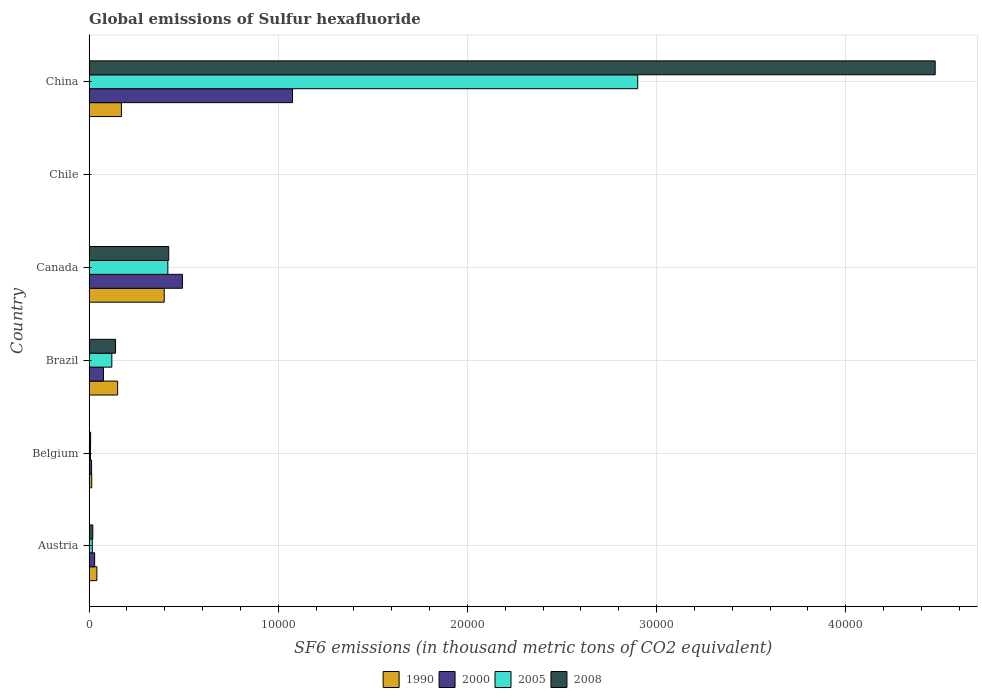How many groups of bars are there?
Your answer should be very brief. 6. What is the label of the 4th group of bars from the top?
Your answer should be compact. Brazil. What is the global emissions of Sulfur hexafluoride in 1990 in Belgium?
Provide a short and direct response. 138.5. Across all countries, what is the maximum global emissions of Sulfur hexafluoride in 2008?
Give a very brief answer. 4.47e+04. In which country was the global emissions of Sulfur hexafluoride in 2000 maximum?
Your response must be concise. China. What is the total global emissions of Sulfur hexafluoride in 2008 in the graph?
Provide a short and direct response. 5.06e+04. What is the difference between the global emissions of Sulfur hexafluoride in 2000 in Brazil and that in Canada?
Offer a terse response. -4176.4. What is the difference between the global emissions of Sulfur hexafluoride in 2008 in Austria and the global emissions of Sulfur hexafluoride in 2000 in Chile?
Give a very brief answer. 189.7. What is the average global emissions of Sulfur hexafluoride in 1990 per country?
Make the answer very short. 1292.42. What is the difference between the global emissions of Sulfur hexafluoride in 1990 and global emissions of Sulfur hexafluoride in 2008 in Belgium?
Keep it short and to the point. 57.6. What is the ratio of the global emissions of Sulfur hexafluoride in 2000 in Austria to that in Canada?
Ensure brevity in your answer.  0.06. What is the difference between the highest and the second highest global emissions of Sulfur hexafluoride in 2008?
Offer a very short reply. 4.05e+04. What is the difference between the highest and the lowest global emissions of Sulfur hexafluoride in 1990?
Your answer should be compact. 3955.3. Is it the case that in every country, the sum of the global emissions of Sulfur hexafluoride in 2000 and global emissions of Sulfur hexafluoride in 2005 is greater than the sum of global emissions of Sulfur hexafluoride in 2008 and global emissions of Sulfur hexafluoride in 1990?
Provide a succinct answer. No. How many bars are there?
Provide a succinct answer. 24. How many countries are there in the graph?
Offer a very short reply. 6. Does the graph contain any zero values?
Make the answer very short. No. Where does the legend appear in the graph?
Your answer should be very brief. Bottom center. What is the title of the graph?
Provide a succinct answer. Global emissions of Sulfur hexafluoride. What is the label or title of the X-axis?
Offer a very short reply. SF6 emissions (in thousand metric tons of CO2 equivalent). What is the SF6 emissions (in thousand metric tons of CO2 equivalent) in 1990 in Austria?
Make the answer very short. 411.2. What is the SF6 emissions (in thousand metric tons of CO2 equivalent) in 2000 in Austria?
Provide a succinct answer. 294.4. What is the SF6 emissions (in thousand metric tons of CO2 equivalent) of 2005 in Austria?
Your response must be concise. 169. What is the SF6 emissions (in thousand metric tons of CO2 equivalent) of 2008 in Austria?
Ensure brevity in your answer.  196.4. What is the SF6 emissions (in thousand metric tons of CO2 equivalent) of 1990 in Belgium?
Your response must be concise. 138.5. What is the SF6 emissions (in thousand metric tons of CO2 equivalent) in 2000 in Belgium?
Ensure brevity in your answer.  131.7. What is the SF6 emissions (in thousand metric tons of CO2 equivalent) of 2005 in Belgium?
Your answer should be very brief. 72.9. What is the SF6 emissions (in thousand metric tons of CO2 equivalent) of 2008 in Belgium?
Your answer should be compact. 80.9. What is the SF6 emissions (in thousand metric tons of CO2 equivalent) of 1990 in Brazil?
Provide a short and direct response. 1507.9. What is the SF6 emissions (in thousand metric tons of CO2 equivalent) in 2000 in Brazil?
Give a very brief answer. 758.7. What is the SF6 emissions (in thousand metric tons of CO2 equivalent) in 2005 in Brazil?
Your answer should be very brief. 1202. What is the SF6 emissions (in thousand metric tons of CO2 equivalent) in 2008 in Brazil?
Offer a very short reply. 1397.3. What is the SF6 emissions (in thousand metric tons of CO2 equivalent) of 1990 in Canada?
Give a very brief answer. 3971.8. What is the SF6 emissions (in thousand metric tons of CO2 equivalent) in 2000 in Canada?
Give a very brief answer. 4935.1. What is the SF6 emissions (in thousand metric tons of CO2 equivalent) in 2005 in Canada?
Ensure brevity in your answer.  4163.8. What is the SF6 emissions (in thousand metric tons of CO2 equivalent) of 2008 in Canada?
Your answer should be very brief. 4208.8. What is the SF6 emissions (in thousand metric tons of CO2 equivalent) in 1990 in China?
Your response must be concise. 1708.6. What is the SF6 emissions (in thousand metric tons of CO2 equivalent) of 2000 in China?
Your response must be concise. 1.08e+04. What is the SF6 emissions (in thousand metric tons of CO2 equivalent) of 2005 in China?
Your response must be concise. 2.90e+04. What is the SF6 emissions (in thousand metric tons of CO2 equivalent) in 2008 in China?
Keep it short and to the point. 4.47e+04. Across all countries, what is the maximum SF6 emissions (in thousand metric tons of CO2 equivalent) in 1990?
Give a very brief answer. 3971.8. Across all countries, what is the maximum SF6 emissions (in thousand metric tons of CO2 equivalent) in 2000?
Offer a very short reply. 1.08e+04. Across all countries, what is the maximum SF6 emissions (in thousand metric tons of CO2 equivalent) of 2005?
Your answer should be compact. 2.90e+04. Across all countries, what is the maximum SF6 emissions (in thousand metric tons of CO2 equivalent) in 2008?
Your answer should be very brief. 4.47e+04. What is the total SF6 emissions (in thousand metric tons of CO2 equivalent) of 1990 in the graph?
Offer a very short reply. 7754.5. What is the total SF6 emissions (in thousand metric tons of CO2 equivalent) in 2000 in the graph?
Provide a succinct answer. 1.69e+04. What is the total SF6 emissions (in thousand metric tons of CO2 equivalent) of 2005 in the graph?
Offer a terse response. 3.46e+04. What is the total SF6 emissions (in thousand metric tons of CO2 equivalent) in 2008 in the graph?
Keep it short and to the point. 5.06e+04. What is the difference between the SF6 emissions (in thousand metric tons of CO2 equivalent) of 1990 in Austria and that in Belgium?
Make the answer very short. 272.7. What is the difference between the SF6 emissions (in thousand metric tons of CO2 equivalent) of 2000 in Austria and that in Belgium?
Provide a short and direct response. 162.7. What is the difference between the SF6 emissions (in thousand metric tons of CO2 equivalent) in 2005 in Austria and that in Belgium?
Provide a succinct answer. 96.1. What is the difference between the SF6 emissions (in thousand metric tons of CO2 equivalent) of 2008 in Austria and that in Belgium?
Your answer should be very brief. 115.5. What is the difference between the SF6 emissions (in thousand metric tons of CO2 equivalent) of 1990 in Austria and that in Brazil?
Keep it short and to the point. -1096.7. What is the difference between the SF6 emissions (in thousand metric tons of CO2 equivalent) in 2000 in Austria and that in Brazil?
Make the answer very short. -464.3. What is the difference between the SF6 emissions (in thousand metric tons of CO2 equivalent) in 2005 in Austria and that in Brazil?
Your response must be concise. -1033. What is the difference between the SF6 emissions (in thousand metric tons of CO2 equivalent) of 2008 in Austria and that in Brazil?
Provide a succinct answer. -1200.9. What is the difference between the SF6 emissions (in thousand metric tons of CO2 equivalent) of 1990 in Austria and that in Canada?
Make the answer very short. -3560.6. What is the difference between the SF6 emissions (in thousand metric tons of CO2 equivalent) of 2000 in Austria and that in Canada?
Offer a terse response. -4640.7. What is the difference between the SF6 emissions (in thousand metric tons of CO2 equivalent) of 2005 in Austria and that in Canada?
Keep it short and to the point. -3994.8. What is the difference between the SF6 emissions (in thousand metric tons of CO2 equivalent) in 2008 in Austria and that in Canada?
Your answer should be compact. -4012.4. What is the difference between the SF6 emissions (in thousand metric tons of CO2 equivalent) in 1990 in Austria and that in Chile?
Your response must be concise. 394.7. What is the difference between the SF6 emissions (in thousand metric tons of CO2 equivalent) of 2000 in Austria and that in Chile?
Offer a terse response. 287.7. What is the difference between the SF6 emissions (in thousand metric tons of CO2 equivalent) of 2005 in Austria and that in Chile?
Ensure brevity in your answer.  160. What is the difference between the SF6 emissions (in thousand metric tons of CO2 equivalent) of 2008 in Austria and that in Chile?
Offer a very short reply. 188.5. What is the difference between the SF6 emissions (in thousand metric tons of CO2 equivalent) of 1990 in Austria and that in China?
Provide a succinct answer. -1297.4. What is the difference between the SF6 emissions (in thousand metric tons of CO2 equivalent) in 2000 in Austria and that in China?
Offer a terse response. -1.05e+04. What is the difference between the SF6 emissions (in thousand metric tons of CO2 equivalent) in 2005 in Austria and that in China?
Provide a short and direct response. -2.88e+04. What is the difference between the SF6 emissions (in thousand metric tons of CO2 equivalent) of 2008 in Austria and that in China?
Ensure brevity in your answer.  -4.45e+04. What is the difference between the SF6 emissions (in thousand metric tons of CO2 equivalent) of 1990 in Belgium and that in Brazil?
Your response must be concise. -1369.4. What is the difference between the SF6 emissions (in thousand metric tons of CO2 equivalent) of 2000 in Belgium and that in Brazil?
Your response must be concise. -627. What is the difference between the SF6 emissions (in thousand metric tons of CO2 equivalent) of 2005 in Belgium and that in Brazil?
Make the answer very short. -1129.1. What is the difference between the SF6 emissions (in thousand metric tons of CO2 equivalent) in 2008 in Belgium and that in Brazil?
Make the answer very short. -1316.4. What is the difference between the SF6 emissions (in thousand metric tons of CO2 equivalent) of 1990 in Belgium and that in Canada?
Your answer should be very brief. -3833.3. What is the difference between the SF6 emissions (in thousand metric tons of CO2 equivalent) in 2000 in Belgium and that in Canada?
Ensure brevity in your answer.  -4803.4. What is the difference between the SF6 emissions (in thousand metric tons of CO2 equivalent) in 2005 in Belgium and that in Canada?
Make the answer very short. -4090.9. What is the difference between the SF6 emissions (in thousand metric tons of CO2 equivalent) of 2008 in Belgium and that in Canada?
Your answer should be compact. -4127.9. What is the difference between the SF6 emissions (in thousand metric tons of CO2 equivalent) in 1990 in Belgium and that in Chile?
Your response must be concise. 122. What is the difference between the SF6 emissions (in thousand metric tons of CO2 equivalent) of 2000 in Belgium and that in Chile?
Give a very brief answer. 125. What is the difference between the SF6 emissions (in thousand metric tons of CO2 equivalent) in 2005 in Belgium and that in Chile?
Provide a short and direct response. 63.9. What is the difference between the SF6 emissions (in thousand metric tons of CO2 equivalent) of 2008 in Belgium and that in Chile?
Offer a terse response. 73. What is the difference between the SF6 emissions (in thousand metric tons of CO2 equivalent) of 1990 in Belgium and that in China?
Keep it short and to the point. -1570.1. What is the difference between the SF6 emissions (in thousand metric tons of CO2 equivalent) in 2000 in Belgium and that in China?
Offer a terse response. -1.06e+04. What is the difference between the SF6 emissions (in thousand metric tons of CO2 equivalent) of 2005 in Belgium and that in China?
Make the answer very short. -2.89e+04. What is the difference between the SF6 emissions (in thousand metric tons of CO2 equivalent) of 2008 in Belgium and that in China?
Make the answer very short. -4.46e+04. What is the difference between the SF6 emissions (in thousand metric tons of CO2 equivalent) in 1990 in Brazil and that in Canada?
Make the answer very short. -2463.9. What is the difference between the SF6 emissions (in thousand metric tons of CO2 equivalent) in 2000 in Brazil and that in Canada?
Your response must be concise. -4176.4. What is the difference between the SF6 emissions (in thousand metric tons of CO2 equivalent) of 2005 in Brazil and that in Canada?
Provide a succinct answer. -2961.8. What is the difference between the SF6 emissions (in thousand metric tons of CO2 equivalent) in 2008 in Brazil and that in Canada?
Your answer should be very brief. -2811.5. What is the difference between the SF6 emissions (in thousand metric tons of CO2 equivalent) of 1990 in Brazil and that in Chile?
Your answer should be very brief. 1491.4. What is the difference between the SF6 emissions (in thousand metric tons of CO2 equivalent) of 2000 in Brazil and that in Chile?
Your answer should be compact. 752. What is the difference between the SF6 emissions (in thousand metric tons of CO2 equivalent) of 2005 in Brazil and that in Chile?
Your answer should be very brief. 1193. What is the difference between the SF6 emissions (in thousand metric tons of CO2 equivalent) of 2008 in Brazil and that in Chile?
Provide a short and direct response. 1389.4. What is the difference between the SF6 emissions (in thousand metric tons of CO2 equivalent) of 1990 in Brazil and that in China?
Provide a short and direct response. -200.7. What is the difference between the SF6 emissions (in thousand metric tons of CO2 equivalent) of 2000 in Brazil and that in China?
Give a very brief answer. -9994.9. What is the difference between the SF6 emissions (in thousand metric tons of CO2 equivalent) in 2005 in Brazil and that in China?
Your answer should be very brief. -2.78e+04. What is the difference between the SF6 emissions (in thousand metric tons of CO2 equivalent) of 2008 in Brazil and that in China?
Keep it short and to the point. -4.33e+04. What is the difference between the SF6 emissions (in thousand metric tons of CO2 equivalent) in 1990 in Canada and that in Chile?
Your answer should be very brief. 3955.3. What is the difference between the SF6 emissions (in thousand metric tons of CO2 equivalent) of 2000 in Canada and that in Chile?
Give a very brief answer. 4928.4. What is the difference between the SF6 emissions (in thousand metric tons of CO2 equivalent) in 2005 in Canada and that in Chile?
Keep it short and to the point. 4154.8. What is the difference between the SF6 emissions (in thousand metric tons of CO2 equivalent) of 2008 in Canada and that in Chile?
Provide a succinct answer. 4200.9. What is the difference between the SF6 emissions (in thousand metric tons of CO2 equivalent) in 1990 in Canada and that in China?
Provide a succinct answer. 2263.2. What is the difference between the SF6 emissions (in thousand metric tons of CO2 equivalent) in 2000 in Canada and that in China?
Give a very brief answer. -5818.5. What is the difference between the SF6 emissions (in thousand metric tons of CO2 equivalent) in 2005 in Canada and that in China?
Offer a very short reply. -2.48e+04. What is the difference between the SF6 emissions (in thousand metric tons of CO2 equivalent) of 2008 in Canada and that in China?
Your answer should be compact. -4.05e+04. What is the difference between the SF6 emissions (in thousand metric tons of CO2 equivalent) of 1990 in Chile and that in China?
Provide a succinct answer. -1692.1. What is the difference between the SF6 emissions (in thousand metric tons of CO2 equivalent) of 2000 in Chile and that in China?
Your answer should be compact. -1.07e+04. What is the difference between the SF6 emissions (in thousand metric tons of CO2 equivalent) in 2005 in Chile and that in China?
Offer a terse response. -2.90e+04. What is the difference between the SF6 emissions (in thousand metric tons of CO2 equivalent) of 2008 in Chile and that in China?
Keep it short and to the point. -4.47e+04. What is the difference between the SF6 emissions (in thousand metric tons of CO2 equivalent) in 1990 in Austria and the SF6 emissions (in thousand metric tons of CO2 equivalent) in 2000 in Belgium?
Offer a very short reply. 279.5. What is the difference between the SF6 emissions (in thousand metric tons of CO2 equivalent) in 1990 in Austria and the SF6 emissions (in thousand metric tons of CO2 equivalent) in 2005 in Belgium?
Provide a short and direct response. 338.3. What is the difference between the SF6 emissions (in thousand metric tons of CO2 equivalent) in 1990 in Austria and the SF6 emissions (in thousand metric tons of CO2 equivalent) in 2008 in Belgium?
Offer a very short reply. 330.3. What is the difference between the SF6 emissions (in thousand metric tons of CO2 equivalent) of 2000 in Austria and the SF6 emissions (in thousand metric tons of CO2 equivalent) of 2005 in Belgium?
Ensure brevity in your answer.  221.5. What is the difference between the SF6 emissions (in thousand metric tons of CO2 equivalent) of 2000 in Austria and the SF6 emissions (in thousand metric tons of CO2 equivalent) of 2008 in Belgium?
Your answer should be very brief. 213.5. What is the difference between the SF6 emissions (in thousand metric tons of CO2 equivalent) of 2005 in Austria and the SF6 emissions (in thousand metric tons of CO2 equivalent) of 2008 in Belgium?
Your response must be concise. 88.1. What is the difference between the SF6 emissions (in thousand metric tons of CO2 equivalent) of 1990 in Austria and the SF6 emissions (in thousand metric tons of CO2 equivalent) of 2000 in Brazil?
Your response must be concise. -347.5. What is the difference between the SF6 emissions (in thousand metric tons of CO2 equivalent) in 1990 in Austria and the SF6 emissions (in thousand metric tons of CO2 equivalent) in 2005 in Brazil?
Make the answer very short. -790.8. What is the difference between the SF6 emissions (in thousand metric tons of CO2 equivalent) of 1990 in Austria and the SF6 emissions (in thousand metric tons of CO2 equivalent) of 2008 in Brazil?
Make the answer very short. -986.1. What is the difference between the SF6 emissions (in thousand metric tons of CO2 equivalent) in 2000 in Austria and the SF6 emissions (in thousand metric tons of CO2 equivalent) in 2005 in Brazil?
Give a very brief answer. -907.6. What is the difference between the SF6 emissions (in thousand metric tons of CO2 equivalent) in 2000 in Austria and the SF6 emissions (in thousand metric tons of CO2 equivalent) in 2008 in Brazil?
Your answer should be compact. -1102.9. What is the difference between the SF6 emissions (in thousand metric tons of CO2 equivalent) in 2005 in Austria and the SF6 emissions (in thousand metric tons of CO2 equivalent) in 2008 in Brazil?
Offer a terse response. -1228.3. What is the difference between the SF6 emissions (in thousand metric tons of CO2 equivalent) in 1990 in Austria and the SF6 emissions (in thousand metric tons of CO2 equivalent) in 2000 in Canada?
Give a very brief answer. -4523.9. What is the difference between the SF6 emissions (in thousand metric tons of CO2 equivalent) in 1990 in Austria and the SF6 emissions (in thousand metric tons of CO2 equivalent) in 2005 in Canada?
Your response must be concise. -3752.6. What is the difference between the SF6 emissions (in thousand metric tons of CO2 equivalent) of 1990 in Austria and the SF6 emissions (in thousand metric tons of CO2 equivalent) of 2008 in Canada?
Provide a succinct answer. -3797.6. What is the difference between the SF6 emissions (in thousand metric tons of CO2 equivalent) in 2000 in Austria and the SF6 emissions (in thousand metric tons of CO2 equivalent) in 2005 in Canada?
Your answer should be very brief. -3869.4. What is the difference between the SF6 emissions (in thousand metric tons of CO2 equivalent) of 2000 in Austria and the SF6 emissions (in thousand metric tons of CO2 equivalent) of 2008 in Canada?
Make the answer very short. -3914.4. What is the difference between the SF6 emissions (in thousand metric tons of CO2 equivalent) of 2005 in Austria and the SF6 emissions (in thousand metric tons of CO2 equivalent) of 2008 in Canada?
Keep it short and to the point. -4039.8. What is the difference between the SF6 emissions (in thousand metric tons of CO2 equivalent) in 1990 in Austria and the SF6 emissions (in thousand metric tons of CO2 equivalent) in 2000 in Chile?
Offer a very short reply. 404.5. What is the difference between the SF6 emissions (in thousand metric tons of CO2 equivalent) of 1990 in Austria and the SF6 emissions (in thousand metric tons of CO2 equivalent) of 2005 in Chile?
Your answer should be very brief. 402.2. What is the difference between the SF6 emissions (in thousand metric tons of CO2 equivalent) in 1990 in Austria and the SF6 emissions (in thousand metric tons of CO2 equivalent) in 2008 in Chile?
Your response must be concise. 403.3. What is the difference between the SF6 emissions (in thousand metric tons of CO2 equivalent) of 2000 in Austria and the SF6 emissions (in thousand metric tons of CO2 equivalent) of 2005 in Chile?
Provide a short and direct response. 285.4. What is the difference between the SF6 emissions (in thousand metric tons of CO2 equivalent) in 2000 in Austria and the SF6 emissions (in thousand metric tons of CO2 equivalent) in 2008 in Chile?
Your answer should be very brief. 286.5. What is the difference between the SF6 emissions (in thousand metric tons of CO2 equivalent) in 2005 in Austria and the SF6 emissions (in thousand metric tons of CO2 equivalent) in 2008 in Chile?
Ensure brevity in your answer.  161.1. What is the difference between the SF6 emissions (in thousand metric tons of CO2 equivalent) of 1990 in Austria and the SF6 emissions (in thousand metric tons of CO2 equivalent) of 2000 in China?
Keep it short and to the point. -1.03e+04. What is the difference between the SF6 emissions (in thousand metric tons of CO2 equivalent) in 1990 in Austria and the SF6 emissions (in thousand metric tons of CO2 equivalent) in 2005 in China?
Offer a terse response. -2.86e+04. What is the difference between the SF6 emissions (in thousand metric tons of CO2 equivalent) of 1990 in Austria and the SF6 emissions (in thousand metric tons of CO2 equivalent) of 2008 in China?
Your answer should be very brief. -4.43e+04. What is the difference between the SF6 emissions (in thousand metric tons of CO2 equivalent) in 2000 in Austria and the SF6 emissions (in thousand metric tons of CO2 equivalent) in 2005 in China?
Your answer should be compact. -2.87e+04. What is the difference between the SF6 emissions (in thousand metric tons of CO2 equivalent) in 2000 in Austria and the SF6 emissions (in thousand metric tons of CO2 equivalent) in 2008 in China?
Keep it short and to the point. -4.44e+04. What is the difference between the SF6 emissions (in thousand metric tons of CO2 equivalent) in 2005 in Austria and the SF6 emissions (in thousand metric tons of CO2 equivalent) in 2008 in China?
Offer a very short reply. -4.46e+04. What is the difference between the SF6 emissions (in thousand metric tons of CO2 equivalent) of 1990 in Belgium and the SF6 emissions (in thousand metric tons of CO2 equivalent) of 2000 in Brazil?
Make the answer very short. -620.2. What is the difference between the SF6 emissions (in thousand metric tons of CO2 equivalent) of 1990 in Belgium and the SF6 emissions (in thousand metric tons of CO2 equivalent) of 2005 in Brazil?
Offer a very short reply. -1063.5. What is the difference between the SF6 emissions (in thousand metric tons of CO2 equivalent) of 1990 in Belgium and the SF6 emissions (in thousand metric tons of CO2 equivalent) of 2008 in Brazil?
Offer a terse response. -1258.8. What is the difference between the SF6 emissions (in thousand metric tons of CO2 equivalent) of 2000 in Belgium and the SF6 emissions (in thousand metric tons of CO2 equivalent) of 2005 in Brazil?
Offer a terse response. -1070.3. What is the difference between the SF6 emissions (in thousand metric tons of CO2 equivalent) in 2000 in Belgium and the SF6 emissions (in thousand metric tons of CO2 equivalent) in 2008 in Brazil?
Ensure brevity in your answer.  -1265.6. What is the difference between the SF6 emissions (in thousand metric tons of CO2 equivalent) in 2005 in Belgium and the SF6 emissions (in thousand metric tons of CO2 equivalent) in 2008 in Brazil?
Keep it short and to the point. -1324.4. What is the difference between the SF6 emissions (in thousand metric tons of CO2 equivalent) of 1990 in Belgium and the SF6 emissions (in thousand metric tons of CO2 equivalent) of 2000 in Canada?
Keep it short and to the point. -4796.6. What is the difference between the SF6 emissions (in thousand metric tons of CO2 equivalent) in 1990 in Belgium and the SF6 emissions (in thousand metric tons of CO2 equivalent) in 2005 in Canada?
Keep it short and to the point. -4025.3. What is the difference between the SF6 emissions (in thousand metric tons of CO2 equivalent) in 1990 in Belgium and the SF6 emissions (in thousand metric tons of CO2 equivalent) in 2008 in Canada?
Your answer should be very brief. -4070.3. What is the difference between the SF6 emissions (in thousand metric tons of CO2 equivalent) in 2000 in Belgium and the SF6 emissions (in thousand metric tons of CO2 equivalent) in 2005 in Canada?
Offer a very short reply. -4032.1. What is the difference between the SF6 emissions (in thousand metric tons of CO2 equivalent) of 2000 in Belgium and the SF6 emissions (in thousand metric tons of CO2 equivalent) of 2008 in Canada?
Make the answer very short. -4077.1. What is the difference between the SF6 emissions (in thousand metric tons of CO2 equivalent) of 2005 in Belgium and the SF6 emissions (in thousand metric tons of CO2 equivalent) of 2008 in Canada?
Provide a succinct answer. -4135.9. What is the difference between the SF6 emissions (in thousand metric tons of CO2 equivalent) in 1990 in Belgium and the SF6 emissions (in thousand metric tons of CO2 equivalent) in 2000 in Chile?
Offer a very short reply. 131.8. What is the difference between the SF6 emissions (in thousand metric tons of CO2 equivalent) of 1990 in Belgium and the SF6 emissions (in thousand metric tons of CO2 equivalent) of 2005 in Chile?
Make the answer very short. 129.5. What is the difference between the SF6 emissions (in thousand metric tons of CO2 equivalent) of 1990 in Belgium and the SF6 emissions (in thousand metric tons of CO2 equivalent) of 2008 in Chile?
Provide a succinct answer. 130.6. What is the difference between the SF6 emissions (in thousand metric tons of CO2 equivalent) in 2000 in Belgium and the SF6 emissions (in thousand metric tons of CO2 equivalent) in 2005 in Chile?
Ensure brevity in your answer.  122.7. What is the difference between the SF6 emissions (in thousand metric tons of CO2 equivalent) of 2000 in Belgium and the SF6 emissions (in thousand metric tons of CO2 equivalent) of 2008 in Chile?
Give a very brief answer. 123.8. What is the difference between the SF6 emissions (in thousand metric tons of CO2 equivalent) of 2005 in Belgium and the SF6 emissions (in thousand metric tons of CO2 equivalent) of 2008 in Chile?
Your response must be concise. 65. What is the difference between the SF6 emissions (in thousand metric tons of CO2 equivalent) of 1990 in Belgium and the SF6 emissions (in thousand metric tons of CO2 equivalent) of 2000 in China?
Give a very brief answer. -1.06e+04. What is the difference between the SF6 emissions (in thousand metric tons of CO2 equivalent) of 1990 in Belgium and the SF6 emissions (in thousand metric tons of CO2 equivalent) of 2005 in China?
Ensure brevity in your answer.  -2.89e+04. What is the difference between the SF6 emissions (in thousand metric tons of CO2 equivalent) of 1990 in Belgium and the SF6 emissions (in thousand metric tons of CO2 equivalent) of 2008 in China?
Provide a succinct answer. -4.46e+04. What is the difference between the SF6 emissions (in thousand metric tons of CO2 equivalent) of 2000 in Belgium and the SF6 emissions (in thousand metric tons of CO2 equivalent) of 2005 in China?
Provide a succinct answer. -2.89e+04. What is the difference between the SF6 emissions (in thousand metric tons of CO2 equivalent) in 2000 in Belgium and the SF6 emissions (in thousand metric tons of CO2 equivalent) in 2008 in China?
Provide a succinct answer. -4.46e+04. What is the difference between the SF6 emissions (in thousand metric tons of CO2 equivalent) of 2005 in Belgium and the SF6 emissions (in thousand metric tons of CO2 equivalent) of 2008 in China?
Your answer should be compact. -4.47e+04. What is the difference between the SF6 emissions (in thousand metric tons of CO2 equivalent) of 1990 in Brazil and the SF6 emissions (in thousand metric tons of CO2 equivalent) of 2000 in Canada?
Keep it short and to the point. -3427.2. What is the difference between the SF6 emissions (in thousand metric tons of CO2 equivalent) of 1990 in Brazil and the SF6 emissions (in thousand metric tons of CO2 equivalent) of 2005 in Canada?
Offer a terse response. -2655.9. What is the difference between the SF6 emissions (in thousand metric tons of CO2 equivalent) of 1990 in Brazil and the SF6 emissions (in thousand metric tons of CO2 equivalent) of 2008 in Canada?
Your response must be concise. -2700.9. What is the difference between the SF6 emissions (in thousand metric tons of CO2 equivalent) of 2000 in Brazil and the SF6 emissions (in thousand metric tons of CO2 equivalent) of 2005 in Canada?
Your response must be concise. -3405.1. What is the difference between the SF6 emissions (in thousand metric tons of CO2 equivalent) of 2000 in Brazil and the SF6 emissions (in thousand metric tons of CO2 equivalent) of 2008 in Canada?
Provide a short and direct response. -3450.1. What is the difference between the SF6 emissions (in thousand metric tons of CO2 equivalent) of 2005 in Brazil and the SF6 emissions (in thousand metric tons of CO2 equivalent) of 2008 in Canada?
Your answer should be very brief. -3006.8. What is the difference between the SF6 emissions (in thousand metric tons of CO2 equivalent) in 1990 in Brazil and the SF6 emissions (in thousand metric tons of CO2 equivalent) in 2000 in Chile?
Give a very brief answer. 1501.2. What is the difference between the SF6 emissions (in thousand metric tons of CO2 equivalent) of 1990 in Brazil and the SF6 emissions (in thousand metric tons of CO2 equivalent) of 2005 in Chile?
Your answer should be very brief. 1498.9. What is the difference between the SF6 emissions (in thousand metric tons of CO2 equivalent) of 1990 in Brazil and the SF6 emissions (in thousand metric tons of CO2 equivalent) of 2008 in Chile?
Your response must be concise. 1500. What is the difference between the SF6 emissions (in thousand metric tons of CO2 equivalent) in 2000 in Brazil and the SF6 emissions (in thousand metric tons of CO2 equivalent) in 2005 in Chile?
Your answer should be very brief. 749.7. What is the difference between the SF6 emissions (in thousand metric tons of CO2 equivalent) of 2000 in Brazil and the SF6 emissions (in thousand metric tons of CO2 equivalent) of 2008 in Chile?
Ensure brevity in your answer.  750.8. What is the difference between the SF6 emissions (in thousand metric tons of CO2 equivalent) in 2005 in Brazil and the SF6 emissions (in thousand metric tons of CO2 equivalent) in 2008 in Chile?
Make the answer very short. 1194.1. What is the difference between the SF6 emissions (in thousand metric tons of CO2 equivalent) in 1990 in Brazil and the SF6 emissions (in thousand metric tons of CO2 equivalent) in 2000 in China?
Your answer should be very brief. -9245.7. What is the difference between the SF6 emissions (in thousand metric tons of CO2 equivalent) in 1990 in Brazil and the SF6 emissions (in thousand metric tons of CO2 equivalent) in 2005 in China?
Your response must be concise. -2.75e+04. What is the difference between the SF6 emissions (in thousand metric tons of CO2 equivalent) in 1990 in Brazil and the SF6 emissions (in thousand metric tons of CO2 equivalent) in 2008 in China?
Keep it short and to the point. -4.32e+04. What is the difference between the SF6 emissions (in thousand metric tons of CO2 equivalent) in 2000 in Brazil and the SF6 emissions (in thousand metric tons of CO2 equivalent) in 2005 in China?
Offer a terse response. -2.82e+04. What is the difference between the SF6 emissions (in thousand metric tons of CO2 equivalent) of 2000 in Brazil and the SF6 emissions (in thousand metric tons of CO2 equivalent) of 2008 in China?
Your answer should be very brief. -4.40e+04. What is the difference between the SF6 emissions (in thousand metric tons of CO2 equivalent) in 2005 in Brazil and the SF6 emissions (in thousand metric tons of CO2 equivalent) in 2008 in China?
Give a very brief answer. -4.35e+04. What is the difference between the SF6 emissions (in thousand metric tons of CO2 equivalent) in 1990 in Canada and the SF6 emissions (in thousand metric tons of CO2 equivalent) in 2000 in Chile?
Provide a short and direct response. 3965.1. What is the difference between the SF6 emissions (in thousand metric tons of CO2 equivalent) in 1990 in Canada and the SF6 emissions (in thousand metric tons of CO2 equivalent) in 2005 in Chile?
Keep it short and to the point. 3962.8. What is the difference between the SF6 emissions (in thousand metric tons of CO2 equivalent) in 1990 in Canada and the SF6 emissions (in thousand metric tons of CO2 equivalent) in 2008 in Chile?
Make the answer very short. 3963.9. What is the difference between the SF6 emissions (in thousand metric tons of CO2 equivalent) of 2000 in Canada and the SF6 emissions (in thousand metric tons of CO2 equivalent) of 2005 in Chile?
Provide a succinct answer. 4926.1. What is the difference between the SF6 emissions (in thousand metric tons of CO2 equivalent) in 2000 in Canada and the SF6 emissions (in thousand metric tons of CO2 equivalent) in 2008 in Chile?
Make the answer very short. 4927.2. What is the difference between the SF6 emissions (in thousand metric tons of CO2 equivalent) of 2005 in Canada and the SF6 emissions (in thousand metric tons of CO2 equivalent) of 2008 in Chile?
Your response must be concise. 4155.9. What is the difference between the SF6 emissions (in thousand metric tons of CO2 equivalent) in 1990 in Canada and the SF6 emissions (in thousand metric tons of CO2 equivalent) in 2000 in China?
Your response must be concise. -6781.8. What is the difference between the SF6 emissions (in thousand metric tons of CO2 equivalent) in 1990 in Canada and the SF6 emissions (in thousand metric tons of CO2 equivalent) in 2005 in China?
Your answer should be compact. -2.50e+04. What is the difference between the SF6 emissions (in thousand metric tons of CO2 equivalent) of 1990 in Canada and the SF6 emissions (in thousand metric tons of CO2 equivalent) of 2008 in China?
Ensure brevity in your answer.  -4.08e+04. What is the difference between the SF6 emissions (in thousand metric tons of CO2 equivalent) of 2000 in Canada and the SF6 emissions (in thousand metric tons of CO2 equivalent) of 2005 in China?
Give a very brief answer. -2.41e+04. What is the difference between the SF6 emissions (in thousand metric tons of CO2 equivalent) of 2000 in Canada and the SF6 emissions (in thousand metric tons of CO2 equivalent) of 2008 in China?
Make the answer very short. -3.98e+04. What is the difference between the SF6 emissions (in thousand metric tons of CO2 equivalent) in 2005 in Canada and the SF6 emissions (in thousand metric tons of CO2 equivalent) in 2008 in China?
Your response must be concise. -4.06e+04. What is the difference between the SF6 emissions (in thousand metric tons of CO2 equivalent) of 1990 in Chile and the SF6 emissions (in thousand metric tons of CO2 equivalent) of 2000 in China?
Your response must be concise. -1.07e+04. What is the difference between the SF6 emissions (in thousand metric tons of CO2 equivalent) of 1990 in Chile and the SF6 emissions (in thousand metric tons of CO2 equivalent) of 2005 in China?
Your response must be concise. -2.90e+04. What is the difference between the SF6 emissions (in thousand metric tons of CO2 equivalent) in 1990 in Chile and the SF6 emissions (in thousand metric tons of CO2 equivalent) in 2008 in China?
Provide a succinct answer. -4.47e+04. What is the difference between the SF6 emissions (in thousand metric tons of CO2 equivalent) in 2000 in Chile and the SF6 emissions (in thousand metric tons of CO2 equivalent) in 2005 in China?
Provide a succinct answer. -2.90e+04. What is the difference between the SF6 emissions (in thousand metric tons of CO2 equivalent) in 2000 in Chile and the SF6 emissions (in thousand metric tons of CO2 equivalent) in 2008 in China?
Your response must be concise. -4.47e+04. What is the difference between the SF6 emissions (in thousand metric tons of CO2 equivalent) in 2005 in Chile and the SF6 emissions (in thousand metric tons of CO2 equivalent) in 2008 in China?
Offer a terse response. -4.47e+04. What is the average SF6 emissions (in thousand metric tons of CO2 equivalent) of 1990 per country?
Provide a succinct answer. 1292.42. What is the average SF6 emissions (in thousand metric tons of CO2 equivalent) of 2000 per country?
Provide a short and direct response. 2813.37. What is the average SF6 emissions (in thousand metric tons of CO2 equivalent) in 2005 per country?
Give a very brief answer. 5769.57. What is the average SF6 emissions (in thousand metric tons of CO2 equivalent) in 2008 per country?
Make the answer very short. 8436.25. What is the difference between the SF6 emissions (in thousand metric tons of CO2 equivalent) of 1990 and SF6 emissions (in thousand metric tons of CO2 equivalent) of 2000 in Austria?
Provide a succinct answer. 116.8. What is the difference between the SF6 emissions (in thousand metric tons of CO2 equivalent) in 1990 and SF6 emissions (in thousand metric tons of CO2 equivalent) in 2005 in Austria?
Make the answer very short. 242.2. What is the difference between the SF6 emissions (in thousand metric tons of CO2 equivalent) in 1990 and SF6 emissions (in thousand metric tons of CO2 equivalent) in 2008 in Austria?
Your answer should be compact. 214.8. What is the difference between the SF6 emissions (in thousand metric tons of CO2 equivalent) of 2000 and SF6 emissions (in thousand metric tons of CO2 equivalent) of 2005 in Austria?
Offer a very short reply. 125.4. What is the difference between the SF6 emissions (in thousand metric tons of CO2 equivalent) of 2005 and SF6 emissions (in thousand metric tons of CO2 equivalent) of 2008 in Austria?
Offer a terse response. -27.4. What is the difference between the SF6 emissions (in thousand metric tons of CO2 equivalent) in 1990 and SF6 emissions (in thousand metric tons of CO2 equivalent) in 2000 in Belgium?
Make the answer very short. 6.8. What is the difference between the SF6 emissions (in thousand metric tons of CO2 equivalent) of 1990 and SF6 emissions (in thousand metric tons of CO2 equivalent) of 2005 in Belgium?
Ensure brevity in your answer.  65.6. What is the difference between the SF6 emissions (in thousand metric tons of CO2 equivalent) of 1990 and SF6 emissions (in thousand metric tons of CO2 equivalent) of 2008 in Belgium?
Make the answer very short. 57.6. What is the difference between the SF6 emissions (in thousand metric tons of CO2 equivalent) in 2000 and SF6 emissions (in thousand metric tons of CO2 equivalent) in 2005 in Belgium?
Offer a very short reply. 58.8. What is the difference between the SF6 emissions (in thousand metric tons of CO2 equivalent) of 2000 and SF6 emissions (in thousand metric tons of CO2 equivalent) of 2008 in Belgium?
Keep it short and to the point. 50.8. What is the difference between the SF6 emissions (in thousand metric tons of CO2 equivalent) of 1990 and SF6 emissions (in thousand metric tons of CO2 equivalent) of 2000 in Brazil?
Your answer should be very brief. 749.2. What is the difference between the SF6 emissions (in thousand metric tons of CO2 equivalent) in 1990 and SF6 emissions (in thousand metric tons of CO2 equivalent) in 2005 in Brazil?
Your response must be concise. 305.9. What is the difference between the SF6 emissions (in thousand metric tons of CO2 equivalent) in 1990 and SF6 emissions (in thousand metric tons of CO2 equivalent) in 2008 in Brazil?
Keep it short and to the point. 110.6. What is the difference between the SF6 emissions (in thousand metric tons of CO2 equivalent) of 2000 and SF6 emissions (in thousand metric tons of CO2 equivalent) of 2005 in Brazil?
Your response must be concise. -443.3. What is the difference between the SF6 emissions (in thousand metric tons of CO2 equivalent) in 2000 and SF6 emissions (in thousand metric tons of CO2 equivalent) in 2008 in Brazil?
Provide a succinct answer. -638.6. What is the difference between the SF6 emissions (in thousand metric tons of CO2 equivalent) in 2005 and SF6 emissions (in thousand metric tons of CO2 equivalent) in 2008 in Brazil?
Provide a succinct answer. -195.3. What is the difference between the SF6 emissions (in thousand metric tons of CO2 equivalent) of 1990 and SF6 emissions (in thousand metric tons of CO2 equivalent) of 2000 in Canada?
Provide a succinct answer. -963.3. What is the difference between the SF6 emissions (in thousand metric tons of CO2 equivalent) in 1990 and SF6 emissions (in thousand metric tons of CO2 equivalent) in 2005 in Canada?
Make the answer very short. -192. What is the difference between the SF6 emissions (in thousand metric tons of CO2 equivalent) of 1990 and SF6 emissions (in thousand metric tons of CO2 equivalent) of 2008 in Canada?
Offer a very short reply. -237. What is the difference between the SF6 emissions (in thousand metric tons of CO2 equivalent) in 2000 and SF6 emissions (in thousand metric tons of CO2 equivalent) in 2005 in Canada?
Your answer should be very brief. 771.3. What is the difference between the SF6 emissions (in thousand metric tons of CO2 equivalent) in 2000 and SF6 emissions (in thousand metric tons of CO2 equivalent) in 2008 in Canada?
Your answer should be compact. 726.3. What is the difference between the SF6 emissions (in thousand metric tons of CO2 equivalent) in 2005 and SF6 emissions (in thousand metric tons of CO2 equivalent) in 2008 in Canada?
Make the answer very short. -45. What is the difference between the SF6 emissions (in thousand metric tons of CO2 equivalent) of 1990 and SF6 emissions (in thousand metric tons of CO2 equivalent) of 2005 in Chile?
Your response must be concise. 7.5. What is the difference between the SF6 emissions (in thousand metric tons of CO2 equivalent) of 2000 and SF6 emissions (in thousand metric tons of CO2 equivalent) of 2005 in Chile?
Offer a terse response. -2.3. What is the difference between the SF6 emissions (in thousand metric tons of CO2 equivalent) in 2000 and SF6 emissions (in thousand metric tons of CO2 equivalent) in 2008 in Chile?
Provide a succinct answer. -1.2. What is the difference between the SF6 emissions (in thousand metric tons of CO2 equivalent) of 1990 and SF6 emissions (in thousand metric tons of CO2 equivalent) of 2000 in China?
Offer a terse response. -9045. What is the difference between the SF6 emissions (in thousand metric tons of CO2 equivalent) of 1990 and SF6 emissions (in thousand metric tons of CO2 equivalent) of 2005 in China?
Your response must be concise. -2.73e+04. What is the difference between the SF6 emissions (in thousand metric tons of CO2 equivalent) in 1990 and SF6 emissions (in thousand metric tons of CO2 equivalent) in 2008 in China?
Your answer should be compact. -4.30e+04. What is the difference between the SF6 emissions (in thousand metric tons of CO2 equivalent) in 2000 and SF6 emissions (in thousand metric tons of CO2 equivalent) in 2005 in China?
Your answer should be very brief. -1.82e+04. What is the difference between the SF6 emissions (in thousand metric tons of CO2 equivalent) in 2000 and SF6 emissions (in thousand metric tons of CO2 equivalent) in 2008 in China?
Keep it short and to the point. -3.40e+04. What is the difference between the SF6 emissions (in thousand metric tons of CO2 equivalent) of 2005 and SF6 emissions (in thousand metric tons of CO2 equivalent) of 2008 in China?
Your answer should be compact. -1.57e+04. What is the ratio of the SF6 emissions (in thousand metric tons of CO2 equivalent) of 1990 in Austria to that in Belgium?
Provide a succinct answer. 2.97. What is the ratio of the SF6 emissions (in thousand metric tons of CO2 equivalent) in 2000 in Austria to that in Belgium?
Offer a very short reply. 2.24. What is the ratio of the SF6 emissions (in thousand metric tons of CO2 equivalent) in 2005 in Austria to that in Belgium?
Give a very brief answer. 2.32. What is the ratio of the SF6 emissions (in thousand metric tons of CO2 equivalent) of 2008 in Austria to that in Belgium?
Ensure brevity in your answer.  2.43. What is the ratio of the SF6 emissions (in thousand metric tons of CO2 equivalent) of 1990 in Austria to that in Brazil?
Provide a short and direct response. 0.27. What is the ratio of the SF6 emissions (in thousand metric tons of CO2 equivalent) of 2000 in Austria to that in Brazil?
Your answer should be compact. 0.39. What is the ratio of the SF6 emissions (in thousand metric tons of CO2 equivalent) of 2005 in Austria to that in Brazil?
Your answer should be very brief. 0.14. What is the ratio of the SF6 emissions (in thousand metric tons of CO2 equivalent) in 2008 in Austria to that in Brazil?
Provide a short and direct response. 0.14. What is the ratio of the SF6 emissions (in thousand metric tons of CO2 equivalent) in 1990 in Austria to that in Canada?
Offer a terse response. 0.1. What is the ratio of the SF6 emissions (in thousand metric tons of CO2 equivalent) in 2000 in Austria to that in Canada?
Make the answer very short. 0.06. What is the ratio of the SF6 emissions (in thousand metric tons of CO2 equivalent) in 2005 in Austria to that in Canada?
Your answer should be compact. 0.04. What is the ratio of the SF6 emissions (in thousand metric tons of CO2 equivalent) of 2008 in Austria to that in Canada?
Give a very brief answer. 0.05. What is the ratio of the SF6 emissions (in thousand metric tons of CO2 equivalent) in 1990 in Austria to that in Chile?
Your answer should be compact. 24.92. What is the ratio of the SF6 emissions (in thousand metric tons of CO2 equivalent) in 2000 in Austria to that in Chile?
Your answer should be very brief. 43.94. What is the ratio of the SF6 emissions (in thousand metric tons of CO2 equivalent) in 2005 in Austria to that in Chile?
Ensure brevity in your answer.  18.78. What is the ratio of the SF6 emissions (in thousand metric tons of CO2 equivalent) in 2008 in Austria to that in Chile?
Offer a terse response. 24.86. What is the ratio of the SF6 emissions (in thousand metric tons of CO2 equivalent) in 1990 in Austria to that in China?
Ensure brevity in your answer.  0.24. What is the ratio of the SF6 emissions (in thousand metric tons of CO2 equivalent) in 2000 in Austria to that in China?
Ensure brevity in your answer.  0.03. What is the ratio of the SF6 emissions (in thousand metric tons of CO2 equivalent) of 2005 in Austria to that in China?
Offer a terse response. 0.01. What is the ratio of the SF6 emissions (in thousand metric tons of CO2 equivalent) in 2008 in Austria to that in China?
Your answer should be very brief. 0. What is the ratio of the SF6 emissions (in thousand metric tons of CO2 equivalent) in 1990 in Belgium to that in Brazil?
Keep it short and to the point. 0.09. What is the ratio of the SF6 emissions (in thousand metric tons of CO2 equivalent) of 2000 in Belgium to that in Brazil?
Your response must be concise. 0.17. What is the ratio of the SF6 emissions (in thousand metric tons of CO2 equivalent) in 2005 in Belgium to that in Brazil?
Your answer should be very brief. 0.06. What is the ratio of the SF6 emissions (in thousand metric tons of CO2 equivalent) of 2008 in Belgium to that in Brazil?
Give a very brief answer. 0.06. What is the ratio of the SF6 emissions (in thousand metric tons of CO2 equivalent) in 1990 in Belgium to that in Canada?
Your answer should be very brief. 0.03. What is the ratio of the SF6 emissions (in thousand metric tons of CO2 equivalent) in 2000 in Belgium to that in Canada?
Provide a short and direct response. 0.03. What is the ratio of the SF6 emissions (in thousand metric tons of CO2 equivalent) in 2005 in Belgium to that in Canada?
Offer a terse response. 0.02. What is the ratio of the SF6 emissions (in thousand metric tons of CO2 equivalent) in 2008 in Belgium to that in Canada?
Offer a very short reply. 0.02. What is the ratio of the SF6 emissions (in thousand metric tons of CO2 equivalent) in 1990 in Belgium to that in Chile?
Your answer should be very brief. 8.39. What is the ratio of the SF6 emissions (in thousand metric tons of CO2 equivalent) in 2000 in Belgium to that in Chile?
Your response must be concise. 19.66. What is the ratio of the SF6 emissions (in thousand metric tons of CO2 equivalent) of 2005 in Belgium to that in Chile?
Your response must be concise. 8.1. What is the ratio of the SF6 emissions (in thousand metric tons of CO2 equivalent) in 2008 in Belgium to that in Chile?
Your answer should be very brief. 10.24. What is the ratio of the SF6 emissions (in thousand metric tons of CO2 equivalent) of 1990 in Belgium to that in China?
Offer a terse response. 0.08. What is the ratio of the SF6 emissions (in thousand metric tons of CO2 equivalent) of 2000 in Belgium to that in China?
Offer a very short reply. 0.01. What is the ratio of the SF6 emissions (in thousand metric tons of CO2 equivalent) of 2005 in Belgium to that in China?
Give a very brief answer. 0. What is the ratio of the SF6 emissions (in thousand metric tons of CO2 equivalent) in 2008 in Belgium to that in China?
Your answer should be very brief. 0. What is the ratio of the SF6 emissions (in thousand metric tons of CO2 equivalent) of 1990 in Brazil to that in Canada?
Give a very brief answer. 0.38. What is the ratio of the SF6 emissions (in thousand metric tons of CO2 equivalent) of 2000 in Brazil to that in Canada?
Your answer should be very brief. 0.15. What is the ratio of the SF6 emissions (in thousand metric tons of CO2 equivalent) in 2005 in Brazil to that in Canada?
Offer a very short reply. 0.29. What is the ratio of the SF6 emissions (in thousand metric tons of CO2 equivalent) in 2008 in Brazil to that in Canada?
Offer a very short reply. 0.33. What is the ratio of the SF6 emissions (in thousand metric tons of CO2 equivalent) in 1990 in Brazil to that in Chile?
Your answer should be very brief. 91.39. What is the ratio of the SF6 emissions (in thousand metric tons of CO2 equivalent) in 2000 in Brazil to that in Chile?
Your response must be concise. 113.24. What is the ratio of the SF6 emissions (in thousand metric tons of CO2 equivalent) of 2005 in Brazil to that in Chile?
Your answer should be very brief. 133.56. What is the ratio of the SF6 emissions (in thousand metric tons of CO2 equivalent) in 2008 in Brazil to that in Chile?
Offer a terse response. 176.87. What is the ratio of the SF6 emissions (in thousand metric tons of CO2 equivalent) in 1990 in Brazil to that in China?
Your response must be concise. 0.88. What is the ratio of the SF6 emissions (in thousand metric tons of CO2 equivalent) of 2000 in Brazil to that in China?
Make the answer very short. 0.07. What is the ratio of the SF6 emissions (in thousand metric tons of CO2 equivalent) in 2005 in Brazil to that in China?
Give a very brief answer. 0.04. What is the ratio of the SF6 emissions (in thousand metric tons of CO2 equivalent) in 2008 in Brazil to that in China?
Provide a short and direct response. 0.03. What is the ratio of the SF6 emissions (in thousand metric tons of CO2 equivalent) of 1990 in Canada to that in Chile?
Offer a terse response. 240.72. What is the ratio of the SF6 emissions (in thousand metric tons of CO2 equivalent) of 2000 in Canada to that in Chile?
Your answer should be very brief. 736.58. What is the ratio of the SF6 emissions (in thousand metric tons of CO2 equivalent) in 2005 in Canada to that in Chile?
Your answer should be very brief. 462.64. What is the ratio of the SF6 emissions (in thousand metric tons of CO2 equivalent) of 2008 in Canada to that in Chile?
Your answer should be compact. 532.76. What is the ratio of the SF6 emissions (in thousand metric tons of CO2 equivalent) in 1990 in Canada to that in China?
Ensure brevity in your answer.  2.32. What is the ratio of the SF6 emissions (in thousand metric tons of CO2 equivalent) of 2000 in Canada to that in China?
Ensure brevity in your answer.  0.46. What is the ratio of the SF6 emissions (in thousand metric tons of CO2 equivalent) in 2005 in Canada to that in China?
Your response must be concise. 0.14. What is the ratio of the SF6 emissions (in thousand metric tons of CO2 equivalent) in 2008 in Canada to that in China?
Provide a short and direct response. 0.09. What is the ratio of the SF6 emissions (in thousand metric tons of CO2 equivalent) of 1990 in Chile to that in China?
Provide a succinct answer. 0.01. What is the ratio of the SF6 emissions (in thousand metric tons of CO2 equivalent) of 2000 in Chile to that in China?
Offer a terse response. 0. What is the difference between the highest and the second highest SF6 emissions (in thousand metric tons of CO2 equivalent) of 1990?
Offer a very short reply. 2263.2. What is the difference between the highest and the second highest SF6 emissions (in thousand metric tons of CO2 equivalent) in 2000?
Offer a terse response. 5818.5. What is the difference between the highest and the second highest SF6 emissions (in thousand metric tons of CO2 equivalent) of 2005?
Offer a very short reply. 2.48e+04. What is the difference between the highest and the second highest SF6 emissions (in thousand metric tons of CO2 equivalent) of 2008?
Offer a terse response. 4.05e+04. What is the difference between the highest and the lowest SF6 emissions (in thousand metric tons of CO2 equivalent) of 1990?
Make the answer very short. 3955.3. What is the difference between the highest and the lowest SF6 emissions (in thousand metric tons of CO2 equivalent) in 2000?
Your answer should be very brief. 1.07e+04. What is the difference between the highest and the lowest SF6 emissions (in thousand metric tons of CO2 equivalent) in 2005?
Keep it short and to the point. 2.90e+04. What is the difference between the highest and the lowest SF6 emissions (in thousand metric tons of CO2 equivalent) of 2008?
Provide a succinct answer. 4.47e+04. 